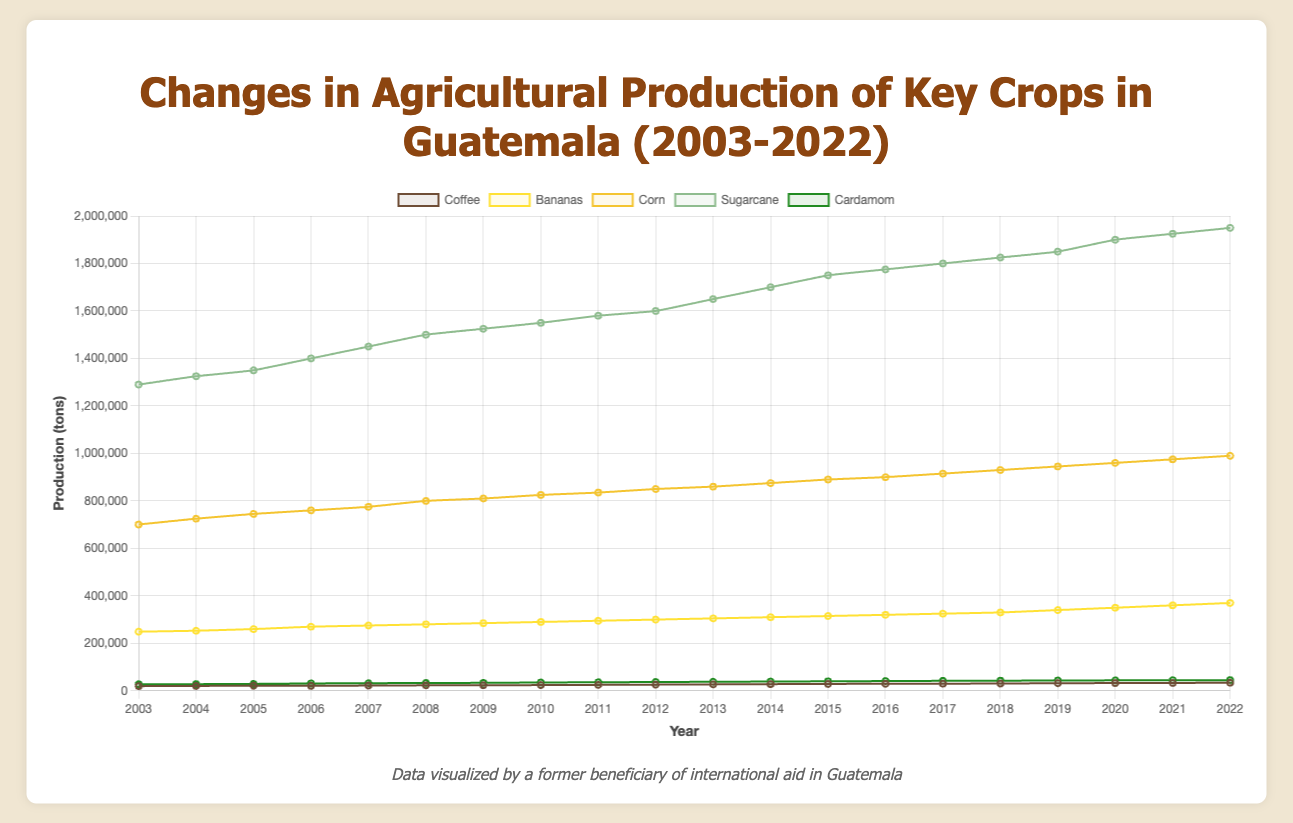What year did corn production first exceed 800,000 tons? Look at the corn line in the chart and find the first year where the value crosses 800,000 tons.
Answer: 2008 How much did coffee production increase from 2003 to 2022? Subtract the coffee production in 2003 from the production in 2022. (34,000 - 19,600) = 14,400 tons
Answer: 14,400 tons What is the trend of banana production over the 20 years? Observe the banana line over the period. It shows a consistent increase from 249,000 tons in 2003 to 370,000 tons in 2022.
Answer: Increasing Which crop had the highest production in 2022? Compare the production levels of all crops in 2022. Sugarcane records the highest value at 1,950,000 tons.
Answer: Sugarcane By how much did sugarcane production increase from 2003 to 2022? Subtract the sugarcane production in 2003 from 2022's production. (1,950,000 - 1,290,000) = 660,000 tons
Answer: 660,000 tons Between which years did cardamom production see the largest increase? Identify the largest difference between consecutive years for cardamom production. The increase from 2013 (38,000 tons) to 2014 (39,000 tons) is the largest (1,000 tons).
Answer: 2013 to 2014 Compare the production level of bananas and corn in 2010. Which one is higher? Check production values for both crops in 2010. Corn (825,000 tons) is higher than bananas (290,000 tons).
Answer: Corn Did coffee production ever decrease during this period? Look at the coffee production line. There was a slight decrease between 2005 (21,500 tons) and 2006 (21,000 tons).
Answer: Yes In which year did sugarcane production first exceed 1,800,000 tons? Locate where the sugarcane line crosses the 1,800,000 tons mark. This occurs in 2017.
Answer: 2017 What was the average annual production of cardamom over the 20 years? Sum all the annual production values of cardamom and divide by 20 years: (27,500 + 28,000 + ... + 45,000) / 20 = 36,625 tons
Answer: 36,625 tons 